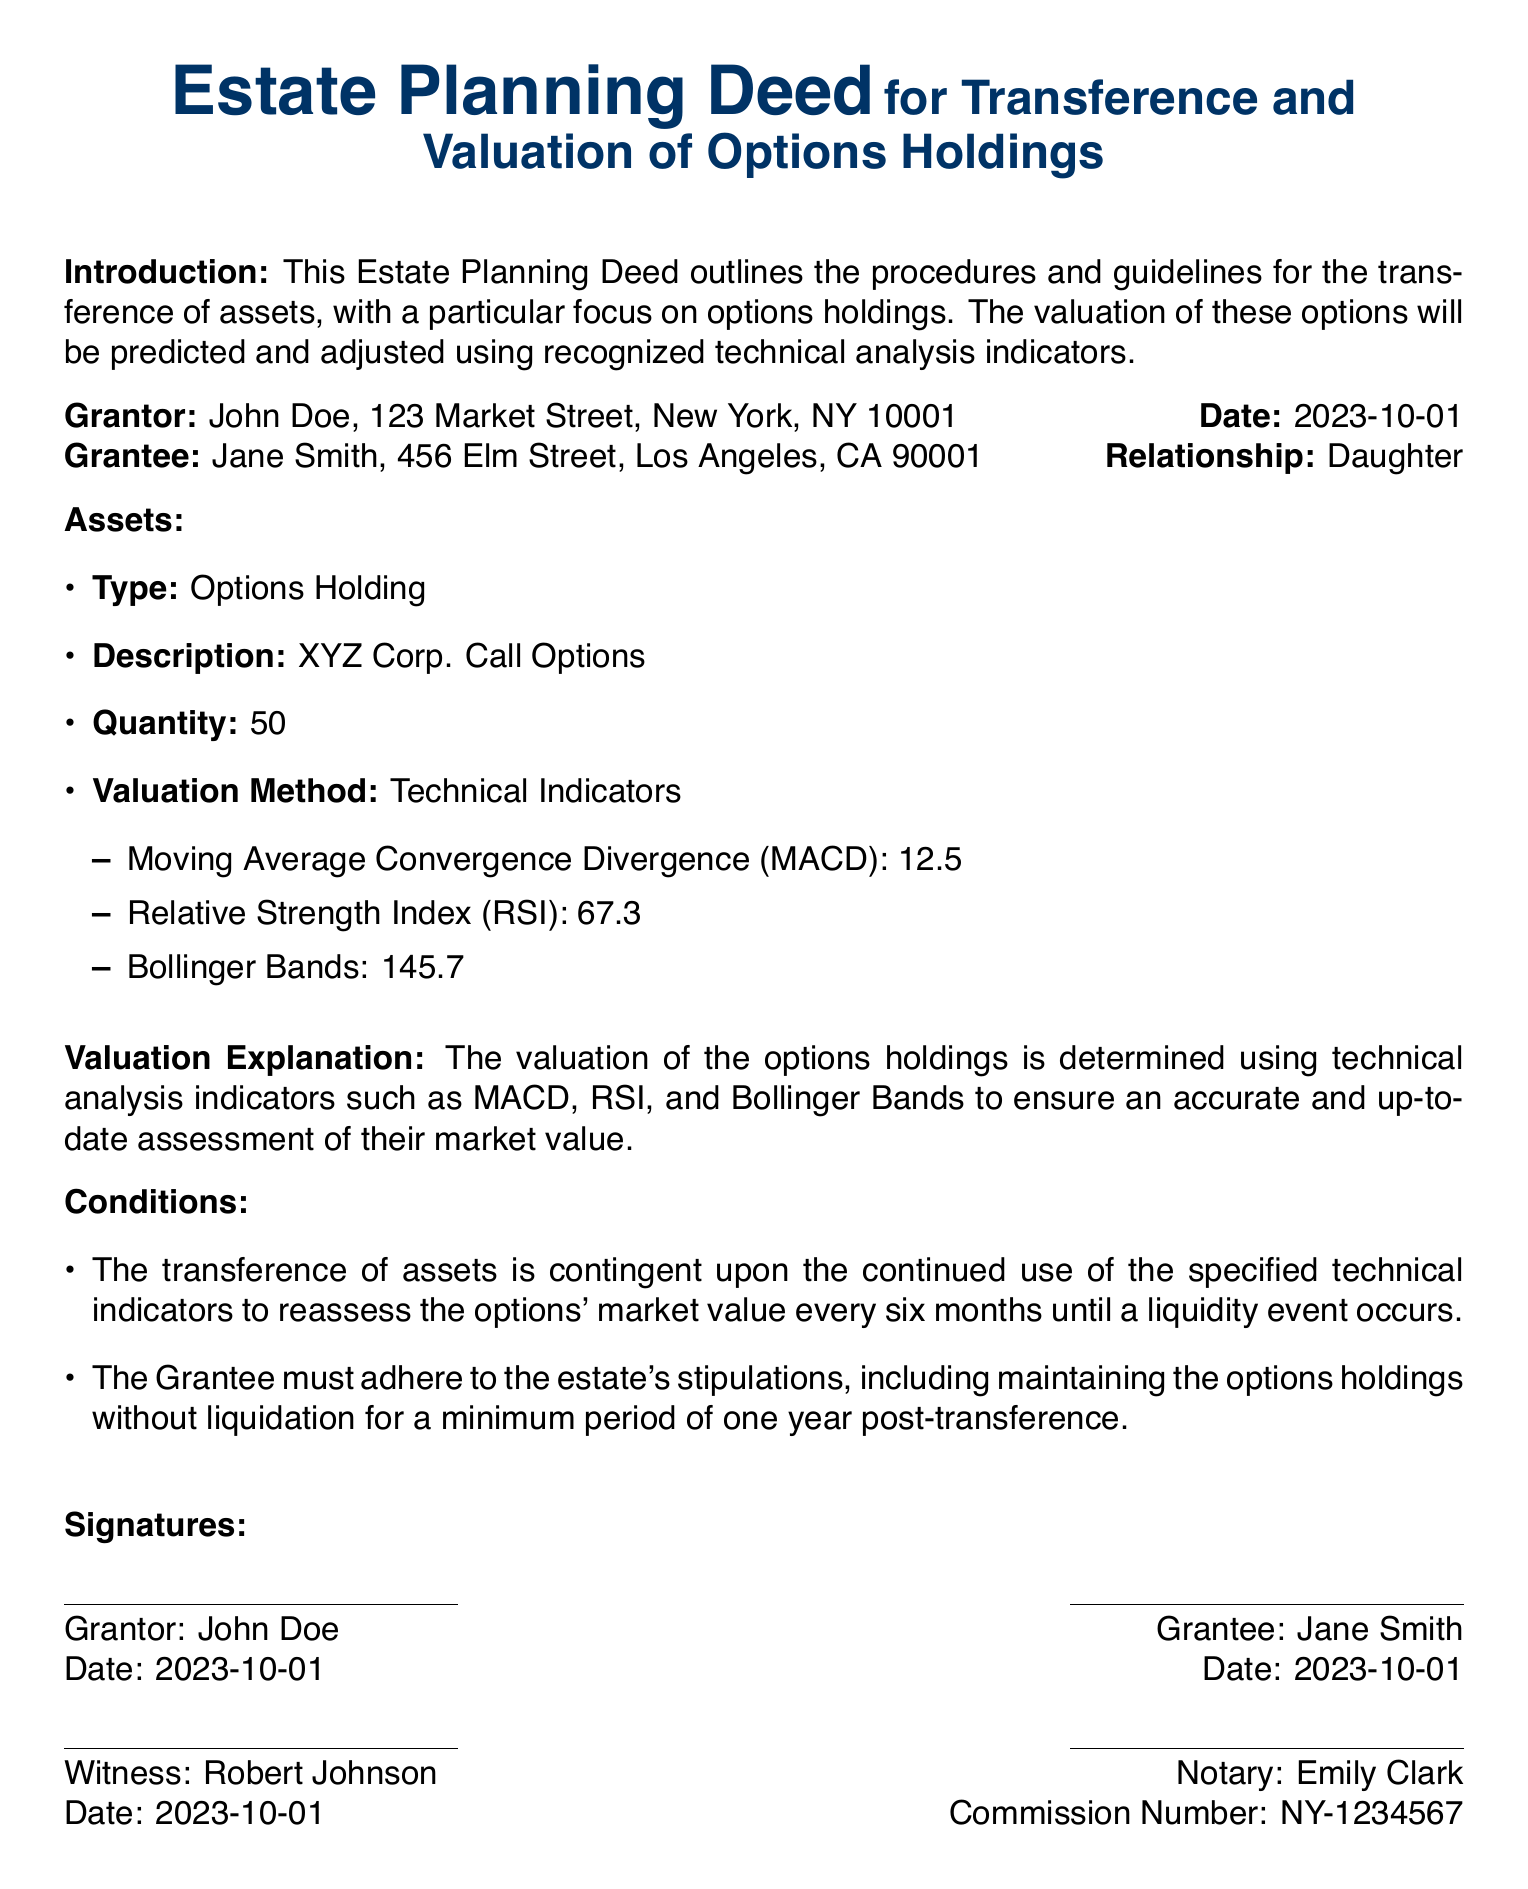What is the name of the Grantor? The document states that the Grantor's name is John Doe.
Answer: John Doe What is the quantity of options holdings being transferred? The document specifies the quantity of options holdings as 50.
Answer: 50 What is the date of the deed? The date mentioned in the document for the deed is October 1, 2023.
Answer: 2023-10-01 What is the relationship of the Grantee to the Grantor? The document indicates that Jane Smith is the Daughter of the Grantor.
Answer: Daughter What is the valuation method used for the options holdings? The document mentions that the valuation method used is Technical Indicators.
Answer: Technical Indicators What must the Grantee do for a minimum period after transference? According to the document, the Grantee must maintain the options holdings without liquidation for at least one year post-transference.
Answer: One year What is the MACD value listed in the document? The document provides the MACD value as 12.5.
Answer: 12.5 What is the condition for reassessing the options' market value? The document states that the reassessment of the options' market value occurs every six months until a liquidity event occurs.
Answer: Every six months Who is the Notary for this deed? The document names Emily Clark as the Notary.
Answer: Emily Clark 